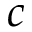<formula> <loc_0><loc_0><loc_500><loc_500>c</formula> 